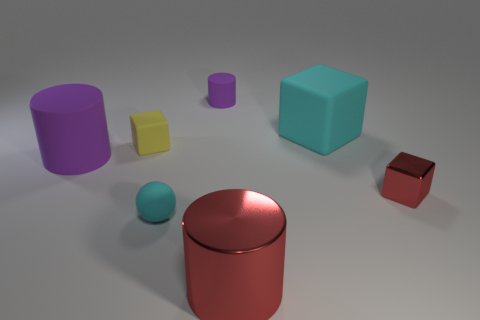There is a red thing that is the same shape as the big cyan rubber object; what size is it?
Give a very brief answer. Small. How many things are large cylinders behind the matte ball or tiny blocks to the left of the red shiny cylinder?
Your answer should be very brief. 2. What is the shape of the big thing that is to the right of the cylinder in front of the big purple object?
Your answer should be very brief. Cube. Is there anything else that is the same color as the big metallic cylinder?
Ensure brevity in your answer.  Yes. Are there any other things that have the same size as the sphere?
Your answer should be very brief. Yes. How many things are small metal cubes or tiny cyan rubber things?
Your response must be concise. 2. Are there any red metal cylinders that have the same size as the red shiny cube?
Your answer should be compact. No. The large red thing is what shape?
Ensure brevity in your answer.  Cylinder. Is the number of large purple rubber objects in front of the large metal cylinder greater than the number of red cylinders on the left side of the tiny yellow object?
Your answer should be very brief. No. Do the large object that is to the right of the big red metal cylinder and the tiny block that is behind the big purple rubber cylinder have the same color?
Provide a short and direct response. No. 